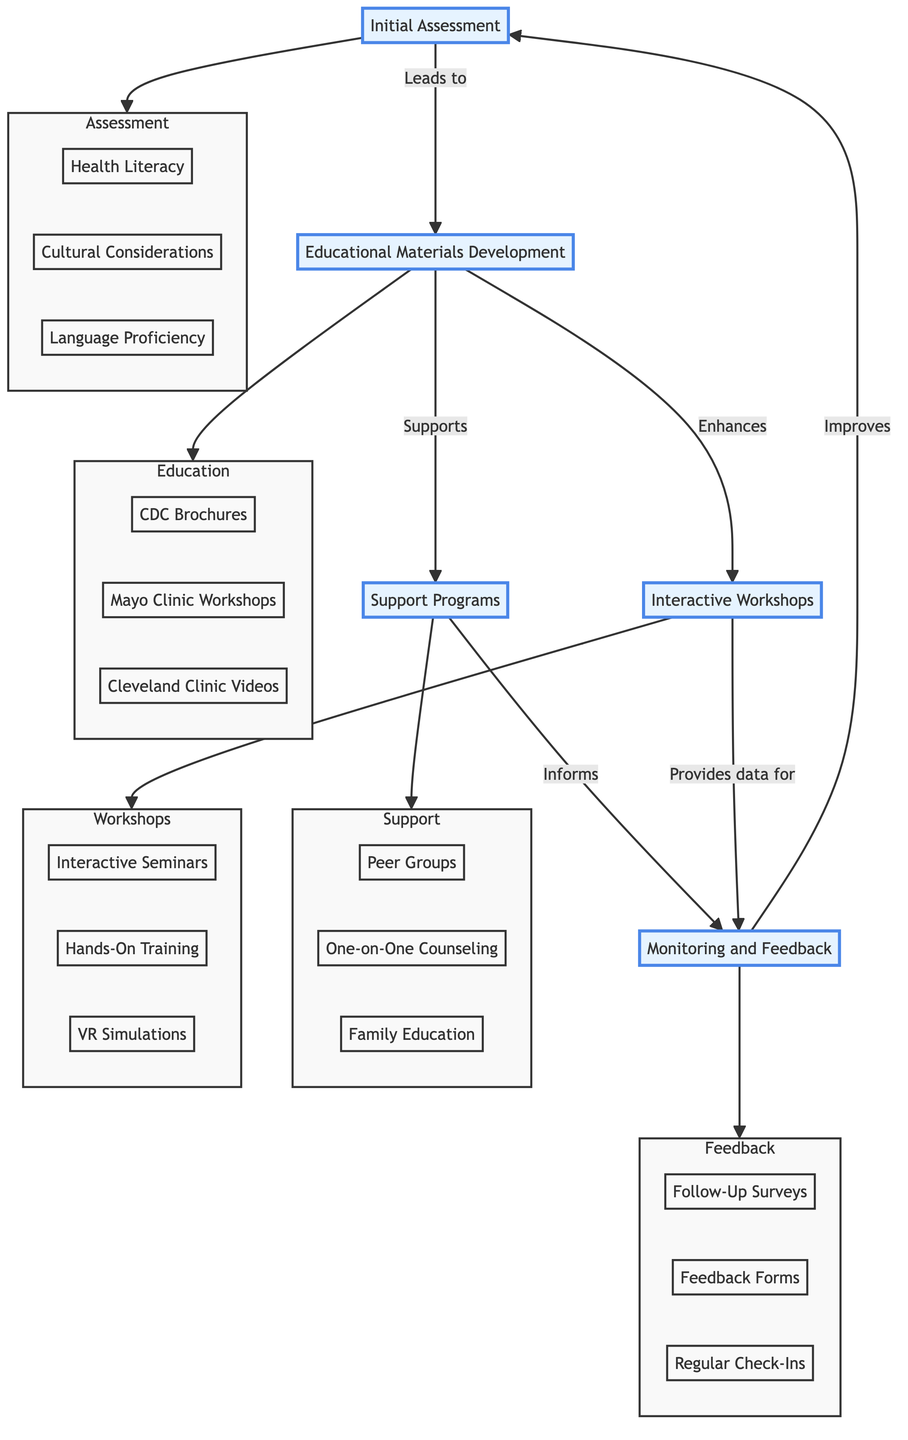What is the first step in the clinical pathway? The diagram indicates that "Initial Assessment" is the first step, as it is the starting node in the flowchart.
Answer: Initial Assessment How many components are in the "Support Programs" node? By examining the "Support Programs" node, it contains three components: Peer Support Groups, One-on-One Counseling, and Family Education Sessions.
Answer: 3 What does the "Educational Materials Development" lead to? The flowchart shows an arrow leading from "Educational Materials Development" to "Support Programs," indicating that it directly supports this node.
Answer: Support Programs Which node provides data for "Monitoring and Feedback"? The diagram specifies that "Interactive Workshops" provides data for "Monitoring and Feedback," as indicated by the corresponding arrow.
Answer: Interactive Workshops What is enhanced by "Educational Materials Development"? The flowchart indicates that "Educational Materials Development" enhances "Interactive Workshops," as shown by the arrow that connects the two nodes.
Answer: Interactive Workshops Which component of "Initial Assessment" focuses on communication? The "Language Proficiency" component is part of "Initial Assessment," focusing on the patient's ability to understand and communicate effectively.
Answer: Language Proficiency How does "Monitoring and Feedback" affect "Initial Assessment"? The diagram indicates that "Monitoring and Feedback" leads to improvements in "Initial Assessment," creating a feedback loop that enhances the patient's education process.
Answer: Improves What type of sessions are included in "Interactive Workshops"? The "Interactive Workshops" node contains components like Interactive Seminars, Hands-On Training Sessions, and Virtual Reality Simulations, classifying the sessions as interactive and engaging.
Answer: Interactive Seminars, Hands-On Training Sessions, Virtual Reality Simulations What kind of evaluation occurs during "Monitoring and Feedback"? "Monitoring and Feedback" continuously evaluates education through components like Follow-Up Surveys and Regular Check-Ins, which assess the effectiveness of patient education.
Answer: Continuous evaluation Which element leads to the development of educational materials? "Initial Assessment" is the element that leads to "Educational Materials Development," as determined by the directed arrow from one to the other in the pathway.
Answer: Educational Materials Development 